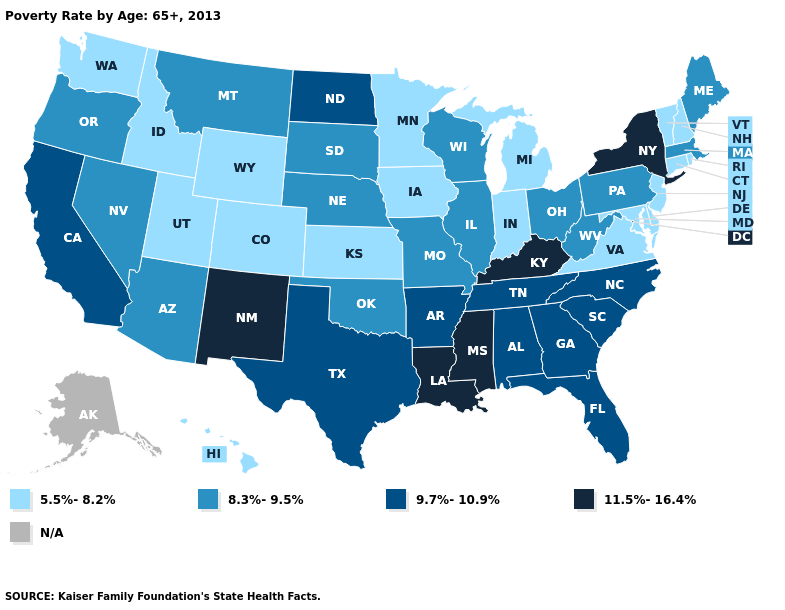What is the value of Delaware?
Quick response, please. 5.5%-8.2%. Is the legend a continuous bar?
Keep it brief. No. What is the value of Tennessee?
Keep it brief. 9.7%-10.9%. Name the states that have a value in the range 5.5%-8.2%?
Write a very short answer. Colorado, Connecticut, Delaware, Hawaii, Idaho, Indiana, Iowa, Kansas, Maryland, Michigan, Minnesota, New Hampshire, New Jersey, Rhode Island, Utah, Vermont, Virginia, Washington, Wyoming. Does Kansas have the lowest value in the MidWest?
Concise answer only. Yes. Which states have the highest value in the USA?
Be succinct. Kentucky, Louisiana, Mississippi, New Mexico, New York. What is the lowest value in the West?
Answer briefly. 5.5%-8.2%. Which states hav the highest value in the Northeast?
Concise answer only. New York. Which states have the lowest value in the South?
Short answer required. Delaware, Maryland, Virginia. What is the lowest value in states that border New Mexico?
Short answer required. 5.5%-8.2%. Which states hav the highest value in the Northeast?
Be succinct. New York. What is the highest value in the MidWest ?
Be succinct. 9.7%-10.9%. Which states have the lowest value in the USA?
Give a very brief answer. Colorado, Connecticut, Delaware, Hawaii, Idaho, Indiana, Iowa, Kansas, Maryland, Michigan, Minnesota, New Hampshire, New Jersey, Rhode Island, Utah, Vermont, Virginia, Washington, Wyoming. 